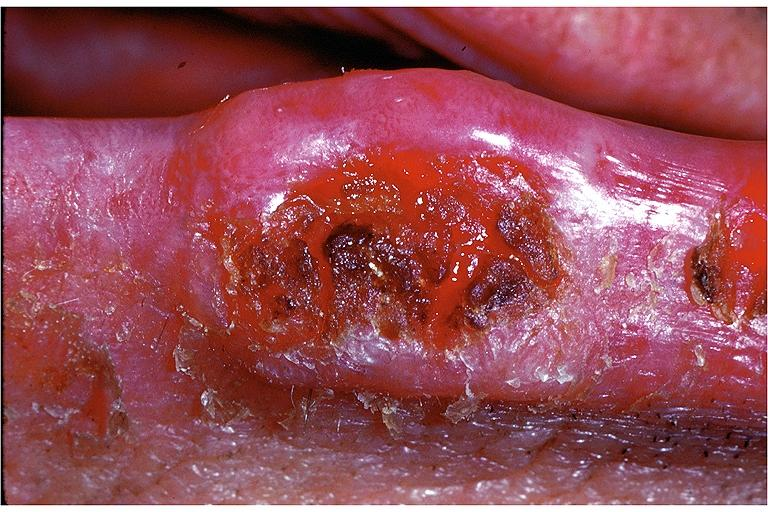where is this?
Answer the question using a single word or phrase. Oral 